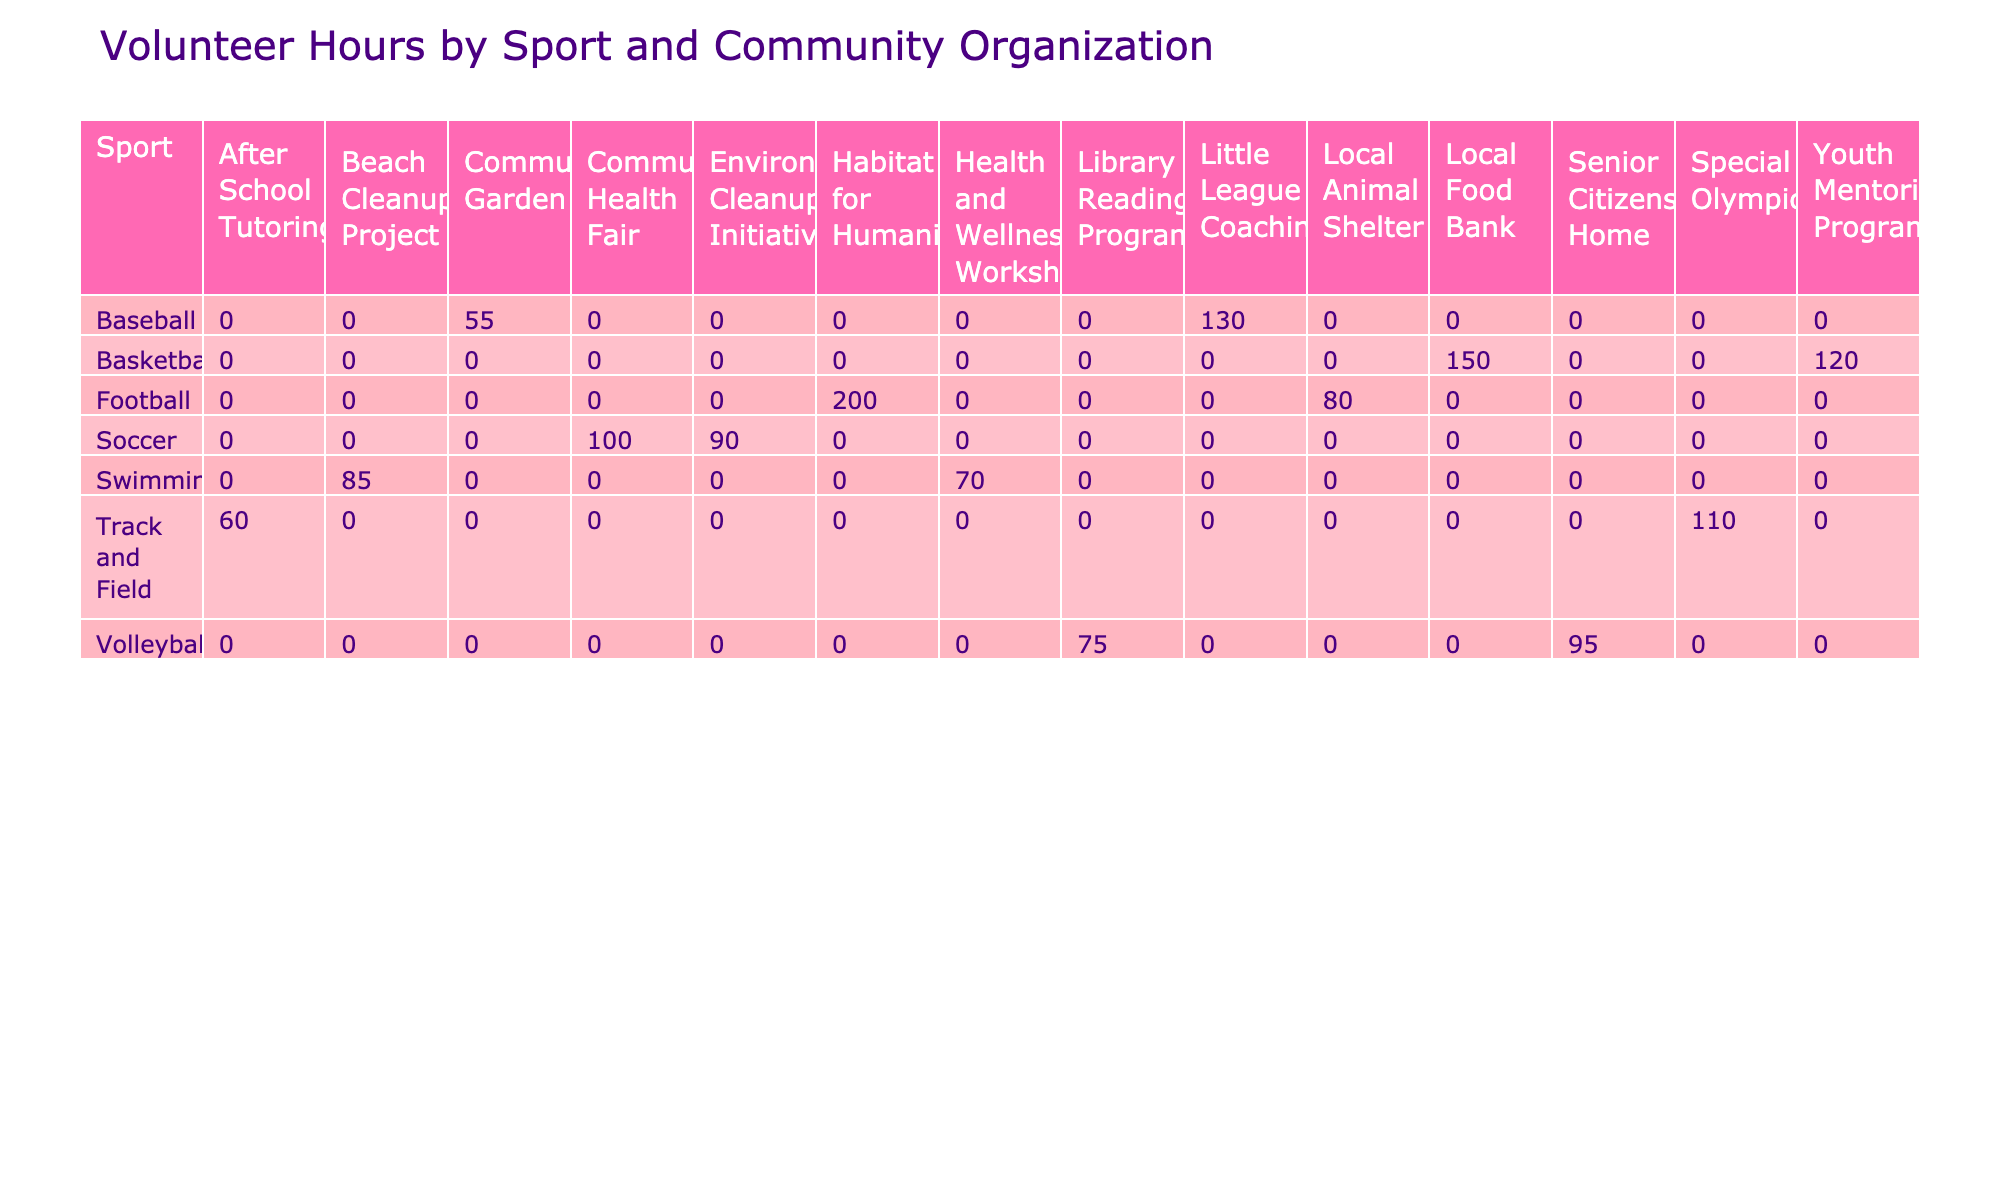What sport has the highest total volunteer hours? By examining the total volunteer hours for each sport presented in the table, we can sum up the hours for each sport. Basketball has 150 + 120 = 270 hours, Football has 200 + 80 = 280 hours, Soccer has 100 + 90 = 190 hours, Track and Field has 60 + 110 = 170 hours, Volleyball has 75 + 95 = 170 hours, Swimming has 70 + 85 = 155 hours, and Baseball has 130 + 55 = 185 hours. Since Football has the highest total at 280 hours, that is the answer.
Answer: Football Which community organization received the most volunteer hours from track and field athletes? Looking at the track and field row in the table, the community organizations listed are After School Tutoring (60 hours) and Special Olympics (110 hours). Comparing these two, Special Olympics received more volunteer hours.
Answer: Special Olympics Did any community organization receive volunteer hours from multiple sports? We can check if any of the community organizations appear in the table across multiple sports. The Local Animal Shelter only received hours from Football, while the Library Reading Program only received hours from Volleyball, and so on. Each community organization is unique to a sport, so none received hours from multiple sports.
Answer: No What is the total number of volunteer hours for volleyball? In the volleyball section of the table, we observe the hours: Library Reading Program received 75 hours and Senior Citizens Home received 95 hours. Adding these values gives us a total of 75 + 95 = 170 hours for volleyball.
Answer: 170 If you combine the volunteer hours of soccer and basketball, how many total volunteer hours do you get? First, we look at the soccer hours: Community Health Fair received 100 hours and Environmental Cleanup Initiative received 90 hours, totaling 100 + 90 = 190 hours. For basketball: Local Food Bank received 150 hours and Youth Mentoring Program received 120 hours, totaling 150 + 120 = 270 hours. Now to find the total for both sports, we add their totals: 190 + 270 = 460 hours.
Answer: 460 